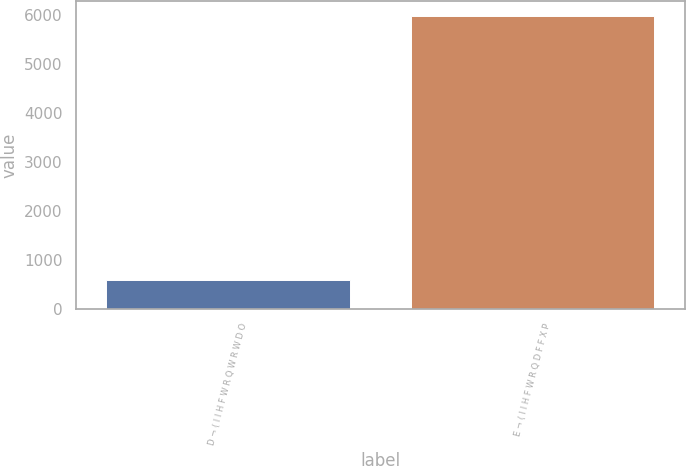<chart> <loc_0><loc_0><loc_500><loc_500><bar_chart><fcel>D ¬ ( I I H F W R Q W R W D O<fcel>E ¬ ( I I H F W R Q D F F X P<nl><fcel>577<fcel>5987<nl></chart> 